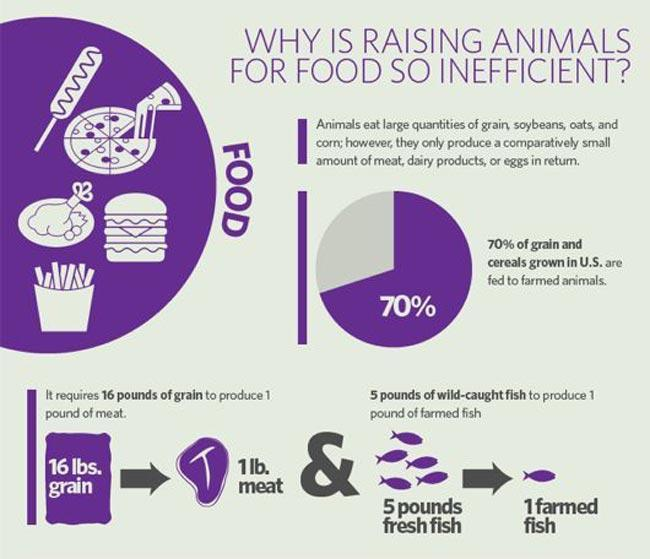What is the grain required in kilograms to produce 1 pound of meat, 16, 5, or 7.25?
Answer the question with a short phrase. 7.25 